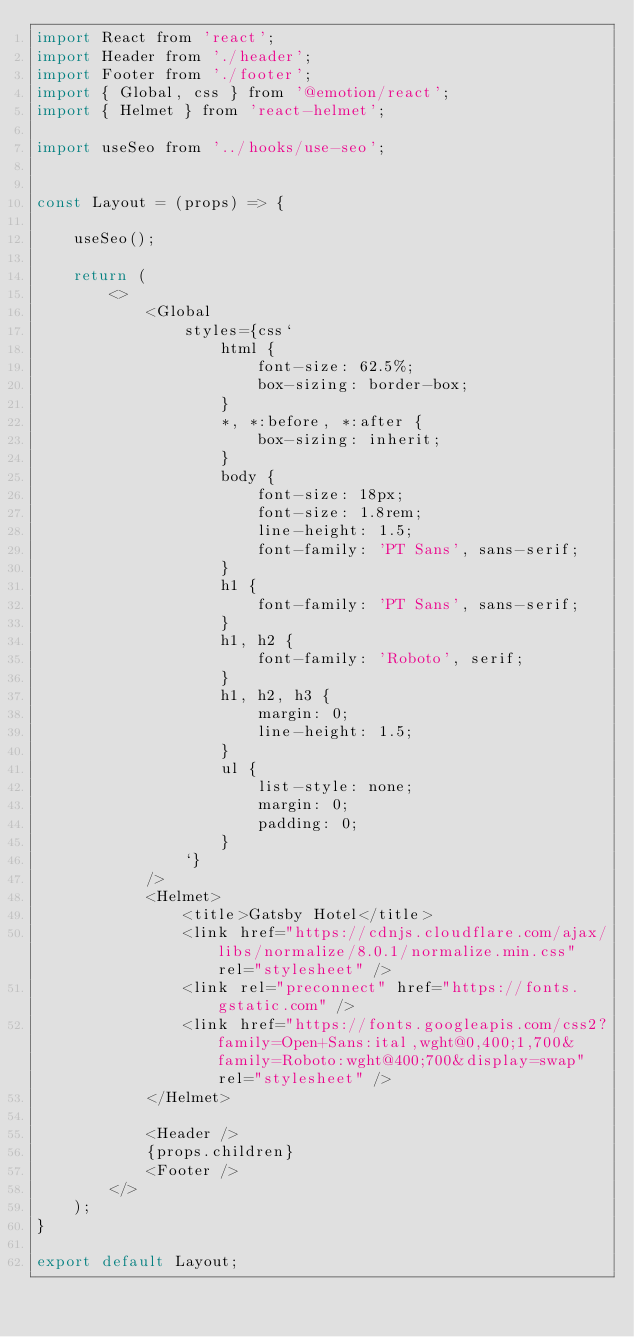Convert code to text. <code><loc_0><loc_0><loc_500><loc_500><_JavaScript_>import React from 'react';
import Header from './header';
import Footer from './footer';
import { Global, css } from '@emotion/react';
import { Helmet } from 'react-helmet';

import useSeo from '../hooks/use-seo';


const Layout = (props) => {

    useSeo();
    
    return (
        <>
            <Global 
                styles={css`
                    html {
                        font-size: 62.5%;
                        box-sizing: border-box;   
                    }
                    *, *:before, *:after {
                        box-sizing: inherit;
                    }
                    body {
                        font-size: 18px;
                        font-size: 1.8rem;
                        line-height: 1.5;
                        font-family: 'PT Sans', sans-serif;
                    }
                    h1 {
                        font-family: 'PT Sans', sans-serif;
                    }
                    h1, h2 {
                        font-family: 'Roboto', serif;
                    }
                    h1, h2, h3 {
                        margin: 0;
                        line-height: 1.5;
                    }
                    ul {
                        list-style: none;
                        margin: 0;
                        padding: 0;
                    }
                `}
            />
            <Helmet>
                <title>Gatsby Hotel</title>
                <link href="https://cdnjs.cloudflare.com/ajax/libs/normalize/8.0.1/normalize.min.css" rel="stylesheet" />
                <link rel="preconnect" href="https://fonts.gstatic.com" />
                <link href="https://fonts.googleapis.com/css2?family=Open+Sans:ital,wght@0,400;1,700&family=Roboto:wght@400;700&display=swap" rel="stylesheet" />
            </Helmet>

            <Header />
            {props.children}
            <Footer />
        </>
    );
}
 
export default Layout;</code> 